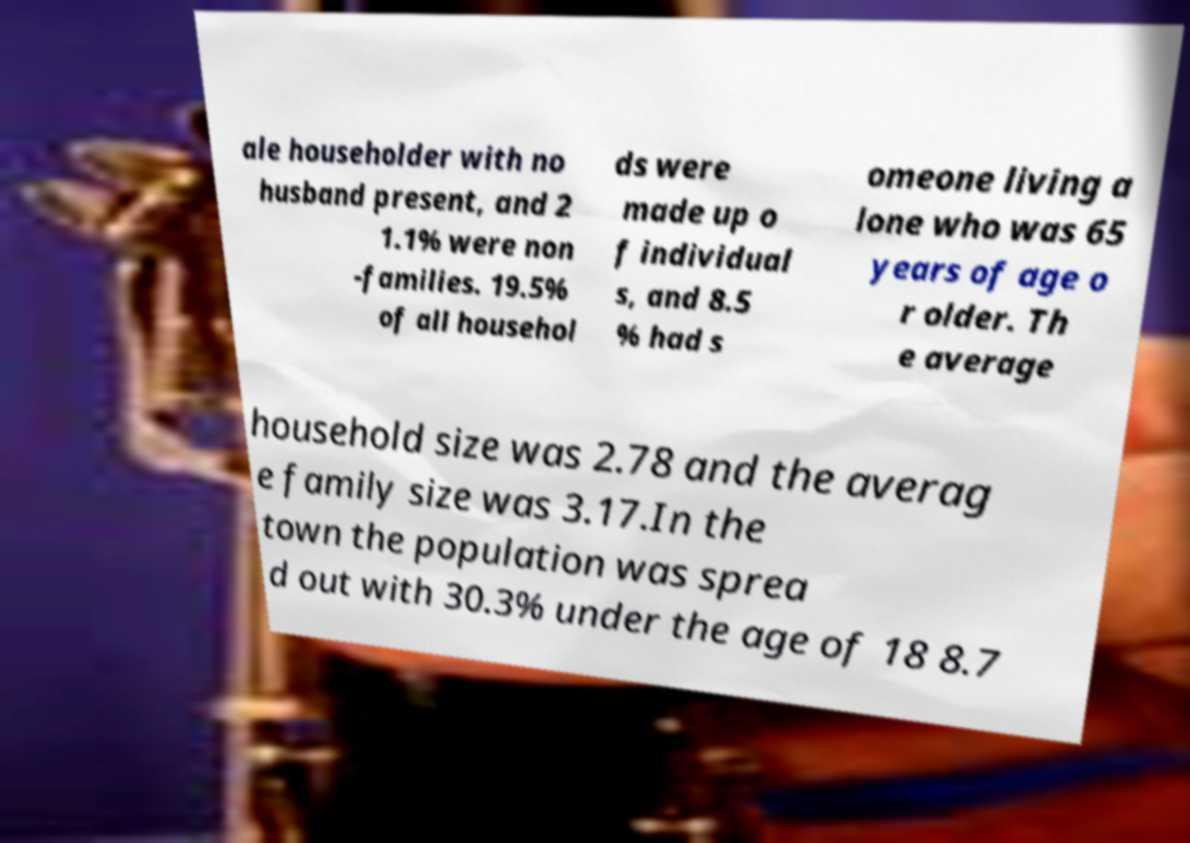Can you read and provide the text displayed in the image?This photo seems to have some interesting text. Can you extract and type it out for me? ale householder with no husband present, and 2 1.1% were non -families. 19.5% of all househol ds were made up o f individual s, and 8.5 % had s omeone living a lone who was 65 years of age o r older. Th e average household size was 2.78 and the averag e family size was 3.17.In the town the population was sprea d out with 30.3% under the age of 18 8.7 